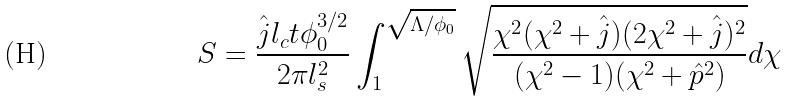<formula> <loc_0><loc_0><loc_500><loc_500>S = \frac { \hat { j } l _ { c } t \phi _ { 0 } ^ { 3 / 2 } } { 2 \pi l _ { s } ^ { 2 } } \int _ { 1 } ^ { \sqrt { \Lambda / \phi _ { 0 } } } \sqrt { \frac { \chi ^ { 2 } ( \chi ^ { 2 } + \hat { j } ) ( 2 \chi ^ { 2 } + \hat { j } ) ^ { 2 } } { ( \chi ^ { 2 } - 1 ) ( \chi ^ { 2 } + \hat { p } ^ { 2 } ) } } d \chi</formula> 